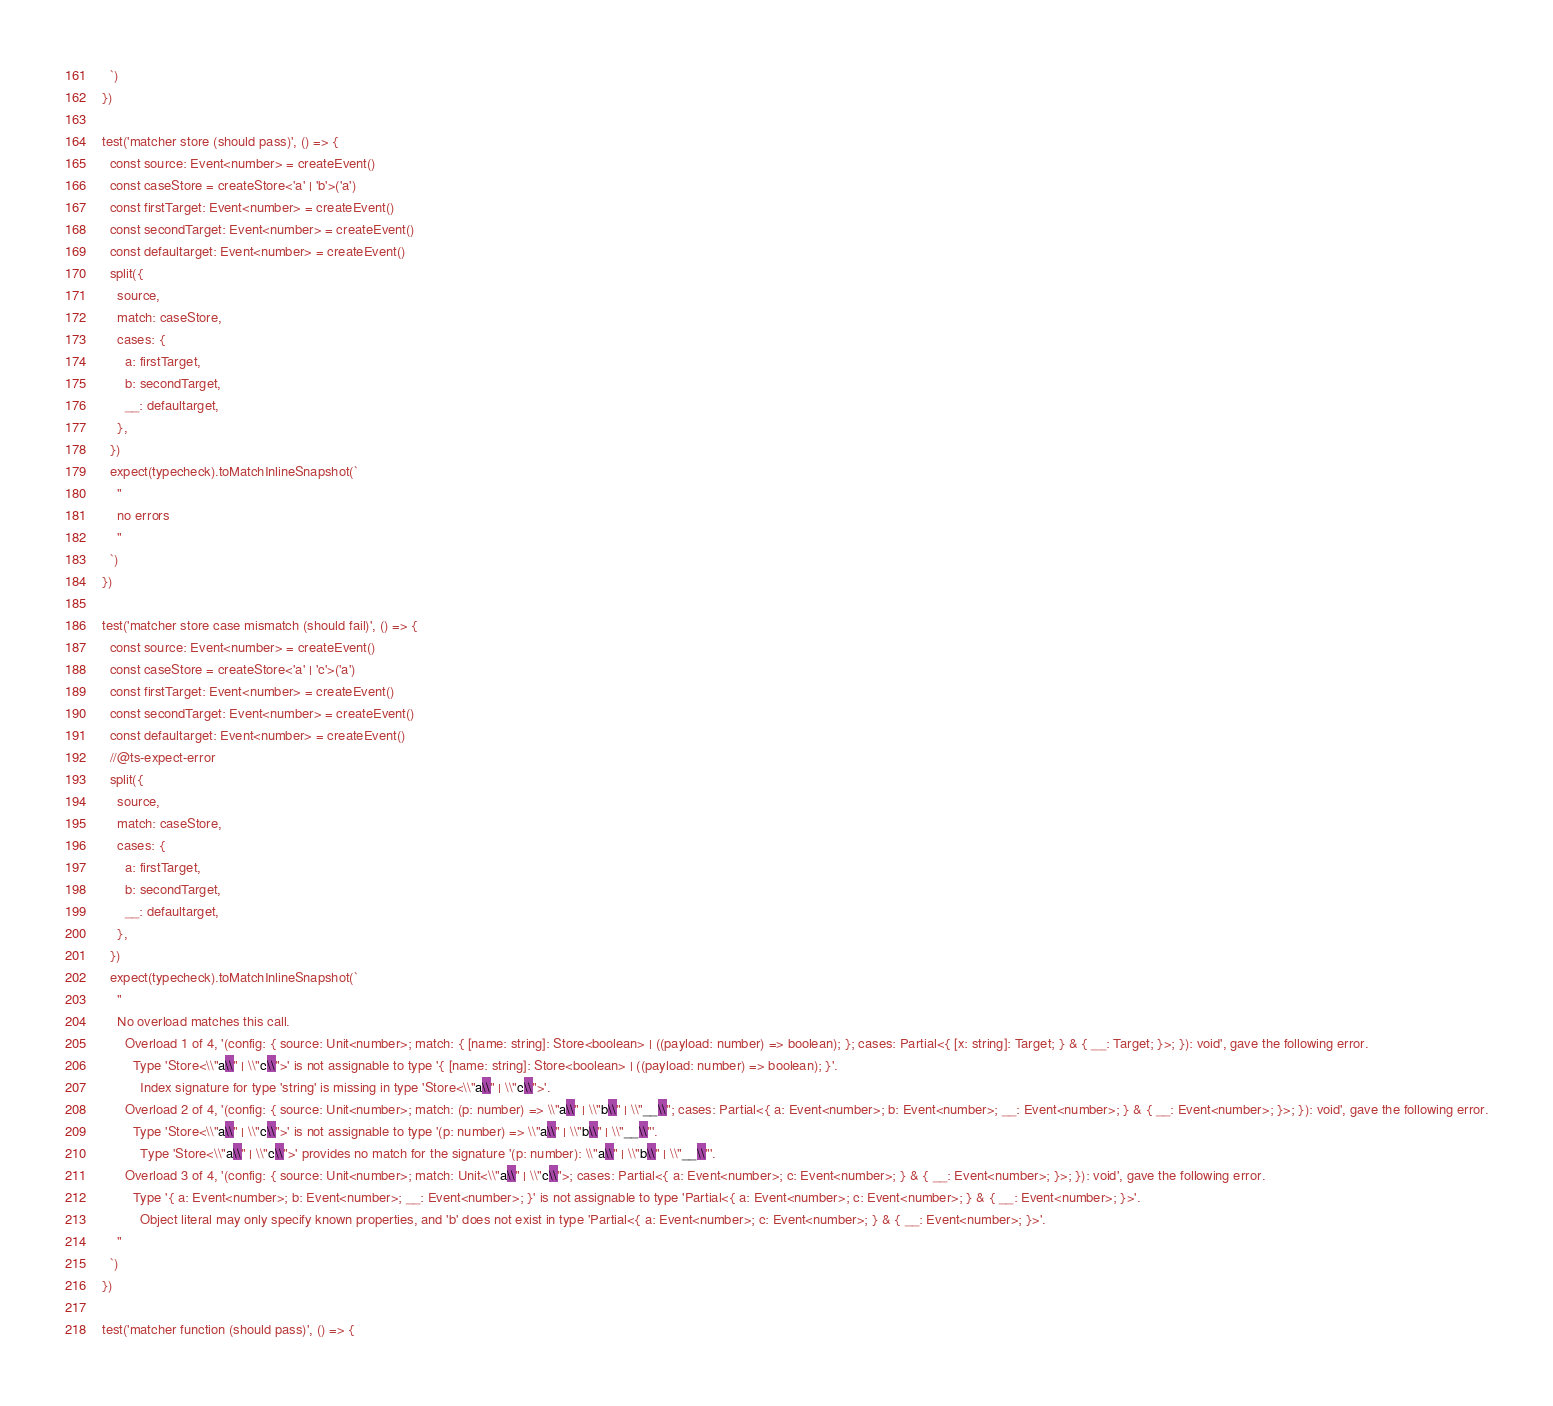<code> <loc_0><loc_0><loc_500><loc_500><_TypeScript_>  `)
})

test('matcher store (should pass)', () => {
  const source: Event<number> = createEvent()
  const caseStore = createStore<'a' | 'b'>('a')
  const firstTarget: Event<number> = createEvent()
  const secondTarget: Event<number> = createEvent()
  const defaultarget: Event<number> = createEvent()
  split({
    source,
    match: caseStore,
    cases: {
      a: firstTarget,
      b: secondTarget,
      __: defaultarget,
    },
  })
  expect(typecheck).toMatchInlineSnapshot(`
    "
    no errors
    "
  `)
})

test('matcher store case mismatch (should fail)', () => {
  const source: Event<number> = createEvent()
  const caseStore = createStore<'a' | 'c'>('a')
  const firstTarget: Event<number> = createEvent()
  const secondTarget: Event<number> = createEvent()
  const defaultarget: Event<number> = createEvent()
  //@ts-expect-error
  split({
    source,
    match: caseStore,
    cases: {
      a: firstTarget,
      b: secondTarget,
      __: defaultarget,
    },
  })
  expect(typecheck).toMatchInlineSnapshot(`
    "
    No overload matches this call.
      Overload 1 of 4, '(config: { source: Unit<number>; match: { [name: string]: Store<boolean> | ((payload: number) => boolean); }; cases: Partial<{ [x: string]: Target; } & { __: Target; }>; }): void', gave the following error.
        Type 'Store<\\"a\\" | \\"c\\">' is not assignable to type '{ [name: string]: Store<boolean> | ((payload: number) => boolean); }'.
          Index signature for type 'string' is missing in type 'Store<\\"a\\" | \\"c\\">'.
      Overload 2 of 4, '(config: { source: Unit<number>; match: (p: number) => \\"a\\" | \\"b\\" | \\"__\\"; cases: Partial<{ a: Event<number>; b: Event<number>; __: Event<number>; } & { __: Event<number>; }>; }): void', gave the following error.
        Type 'Store<\\"a\\" | \\"c\\">' is not assignable to type '(p: number) => \\"a\\" | \\"b\\" | \\"__\\"'.
          Type 'Store<\\"a\\" | \\"c\\">' provides no match for the signature '(p: number): \\"a\\" | \\"b\\" | \\"__\\"'.
      Overload 3 of 4, '(config: { source: Unit<number>; match: Unit<\\"a\\" | \\"c\\">; cases: Partial<{ a: Event<number>; c: Event<number>; } & { __: Event<number>; }>; }): void', gave the following error.
        Type '{ a: Event<number>; b: Event<number>; __: Event<number>; }' is not assignable to type 'Partial<{ a: Event<number>; c: Event<number>; } & { __: Event<number>; }>'.
          Object literal may only specify known properties, and 'b' does not exist in type 'Partial<{ a: Event<number>; c: Event<number>; } & { __: Event<number>; }>'.
    "
  `)
})

test('matcher function (should pass)', () => {</code> 